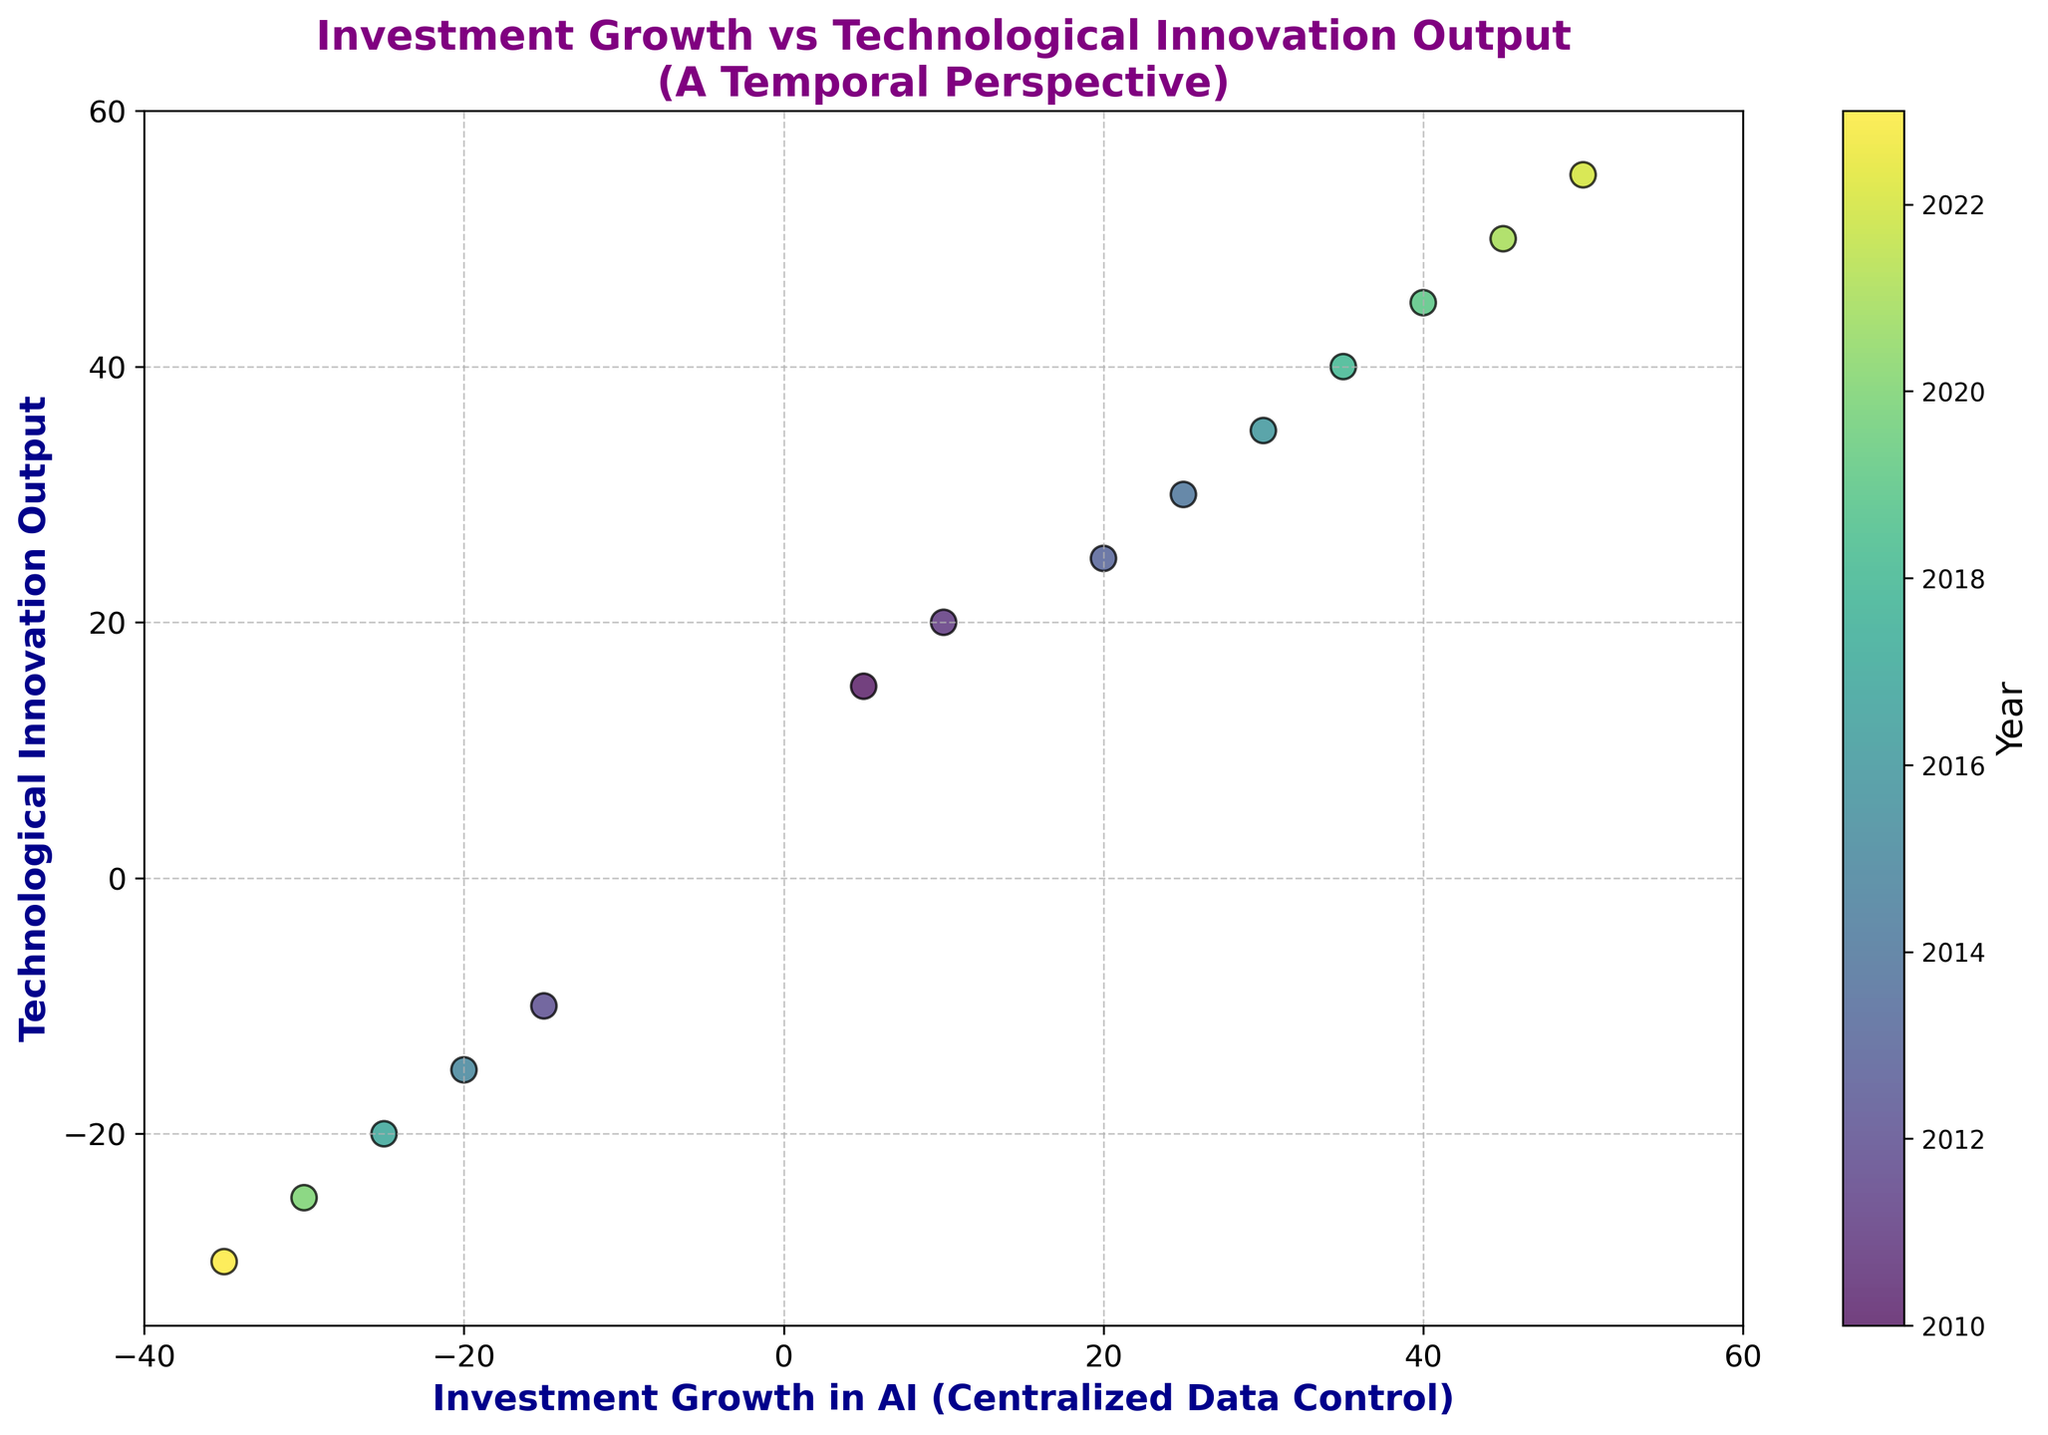What's the year with the highest Investment Growth in AI (Centralized Data Control)? The year with the highest Investment Growth in AI (Centralized Data Control) is the point farthest to the right on the x-axis. This point is at 50, and the corresponding year labeled by color is 2022.
Answer: 2022 What's the average Technological Innovation Output for the years when Investment Growth in AI is negative? First, identify the points where Investment Growth in AI is negative: 2012, 2015, 2017, 2020, and 2023. Their corresponding Technological Innovation Outputs are -10, -15, -20, -25, and -30. Adding these: (-10 + -15 + -20 + -25 + -30) = -100. Dividing by the number of points (5) gives an average of -100/5 = -20.
Answer: -20 During which years does the Investment Growth in AI show a negative trend? Looking for points to the left of zero on the x-axis, we find negative trends in the years: 2012, 2015, 2017, 2020, and 2023.
Answer: 2012, 2015, 2017, 2020, 2023 Is there a correlation observed between Investment Growth in AI and Technological Innovation Output? Observe that as the Investment Growth in AI increases, so does the Technological Innovation Output, and the same is true when both are negative. This indicates a positive correlation between the two variables.
Answer: Yes Which year is represented by the most central visual point in the scatter plot? The most central point visually near the middle of the axes appears to be around (25, 30). The year color-coded for this point is 2014.
Answer: 2014 What's the total number of years where both Investment Growth in AI and Technological Innovation Output are positive? Identify the points where both values are positive: 2010, 2011, 2013, 2014, 2016, 2018, 2019, 2021, and 2022. Counting these gives 9 years.
Answer: 9 Which year has the least Technological Innovation Output amongst the positive Investment Growth values? Amongst points where Investment Growth in AI is positive, we look for the minimum Technological Innovation Output. The year with the smallest Technological Innovation Output, where Investment Growth in AI is positive, is 2010 with a value of 15.
Answer: 2010 What trend can be observed in the scatter plot when comparing centered output values based on their color gradient? Observing the color gradient moving from dark to light colors (from earlier to later years), there's a trend showing increasing values for both Investment Growth in AI and Technological Innovation Output.
Answer: Increasing trend 